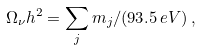<formula> <loc_0><loc_0><loc_500><loc_500>\Omega _ { \nu } h ^ { 2 } = \sum _ { j } m _ { j } / ( 9 3 . 5 \, e V ) \, ,</formula> 